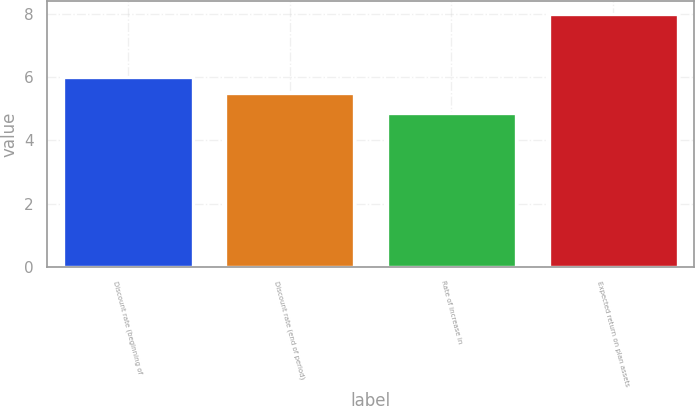<chart> <loc_0><loc_0><loc_500><loc_500><bar_chart><fcel>Discount rate (beginning of<fcel>Discount rate (end of period)<fcel>Rate of increase in<fcel>Expected return on plan assets<nl><fcel>6<fcel>5.5<fcel>4.85<fcel>8<nl></chart> 